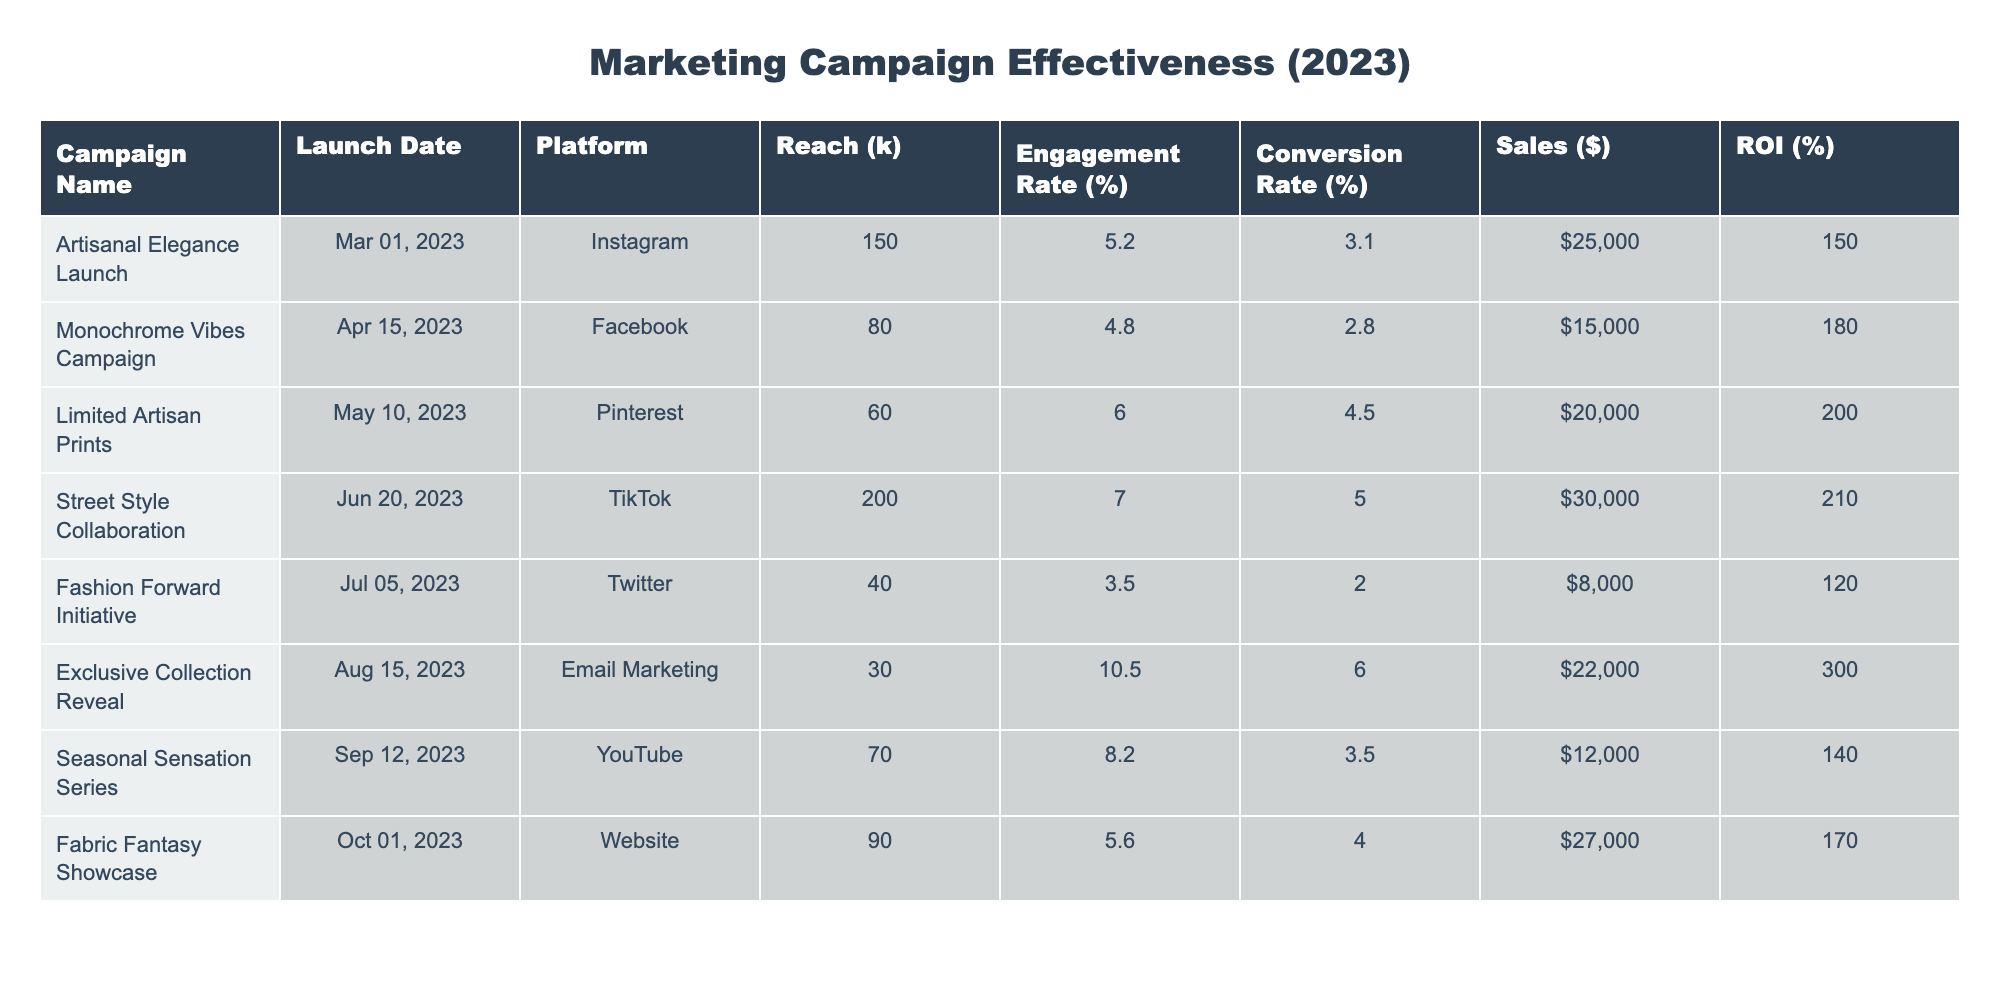What's the total sales generated from the campaigns? To find the total sales, we sum up the sales figures from each campaign: 25000 + 15000 + 20000 + 30000 + 8000 + 22000 + 12000 + 27000 = 130000.
Answer: 130000 Which campaign had the highest engagement rate? By comparing the engagement rates listed, "Exclusive Collection Reveal" has the highest engagement rate of 10.5%.
Answer: 10.5% What is the conversion rate for the "Street Style Collaboration" campaign? The table shows that the conversion rate for the "Street Style Collaboration" campaign is 5.0%.
Answer: 5.0% Is the ROI for the "Limited Artisan Prints" campaign higher than for the "Monochrome Vibes Campaign"? The ROI for "Limited Artisan Prints" is 200%, while for "Monochrome Vibes Campaign" it is 180%. Since 200 > 180, the statement is true.
Answer: Yes What is the average reach across all campaigns? To find the average reach, we sum the reach values: (150 + 80 + 60 + 200 + 40 + 30 + 70 + 90) = 720. There are 8 campaigns, so the average reach is 720 / 8 = 90.
Answer: 90 Which platform generated the least sales? We compare the sales values for each platform: Email Marketing generated 22000, Twitter 8000, and all others are higher. Therefore, Twitter generated the least sales.
Answer: Twitter What is the difference in ROI between the highest and lowest performing campaigns? The highest ROI is from "Exclusive Collection Reveal" at 300%, and the lowest is from "Fashion Forward Initiative" at 120%. The difference is 300 - 120 = 180.
Answer: 180 Which campaign had the least reach and what was its engagement rate? The campaign with the least reach is "Exclusive Collection Reveal," with a reach of 30k and an engagement rate of 10.5%.
Answer: 10.5% What percentage of the campaigns had a conversion rate above 4%? The campaigns with conversion rates above 4% are "Limited Artisan Prints," "Street Style Collaboration," and "Exclusive Collection Reveal," making 3 out of 8 campaigns, which is 3/8 = 37.5%.
Answer: 37.5% Is there a correlation between high reach and high sales in these campaigns? "Street Style Collaboration" has high reach (200k) and high sales ($30000), while "Fashion Forward Initiative" has low reach (40k) and low sales ($8000). However, the correlation can’t be definitively established without calculations for all campaigns, showing mixed performance.
Answer: No 